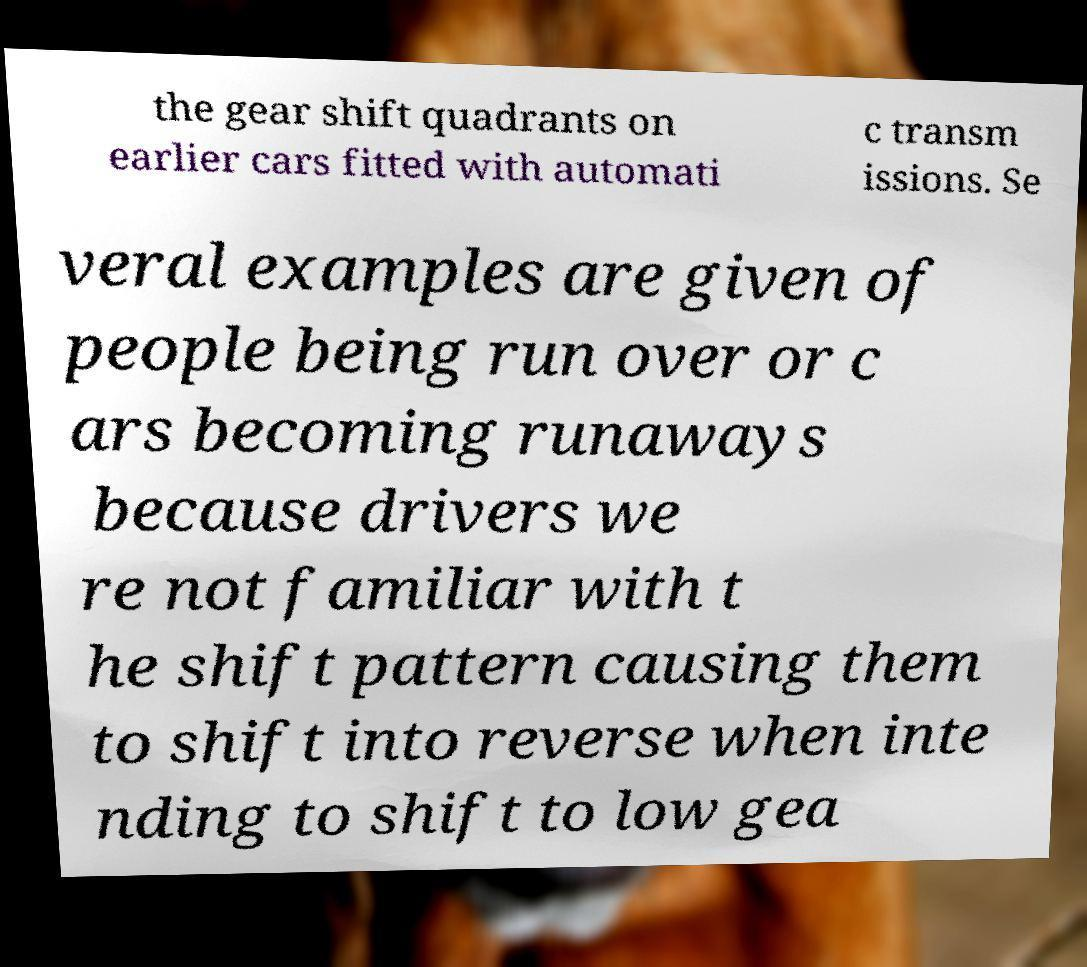Could you assist in decoding the text presented in this image and type it out clearly? the gear shift quadrants on earlier cars fitted with automati c transm issions. Se veral examples are given of people being run over or c ars becoming runaways because drivers we re not familiar with t he shift pattern causing them to shift into reverse when inte nding to shift to low gea 